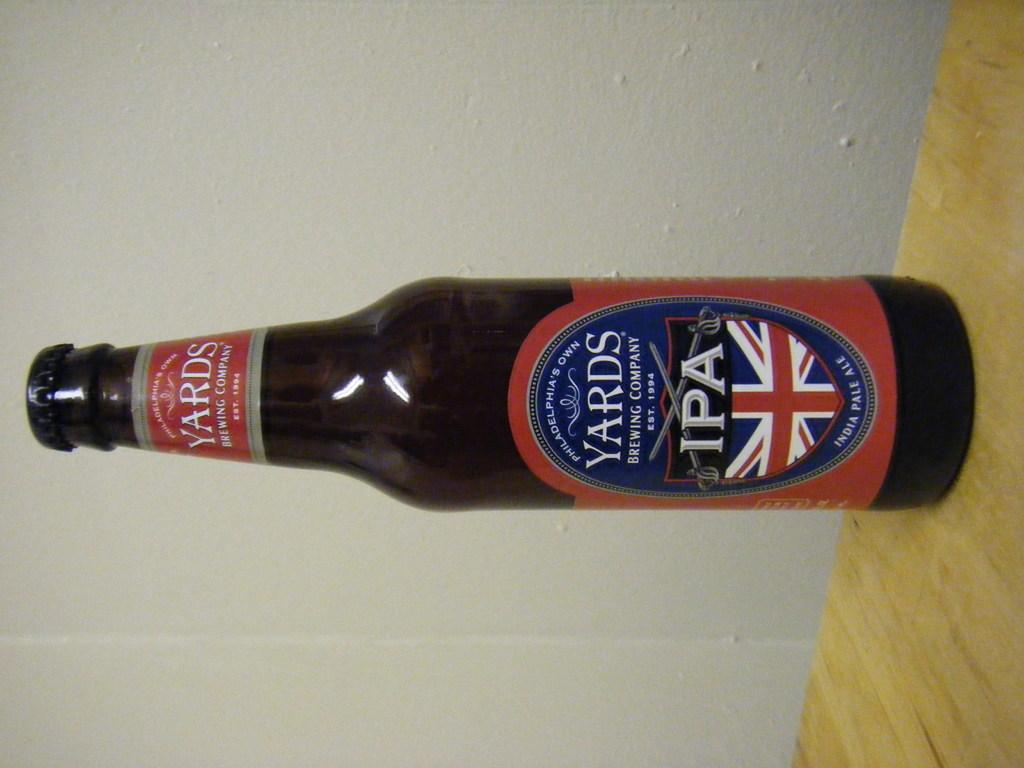Provide a one-sentence caption for the provided image. A British beer names Yards has a blue, red and white label with a flag design. 